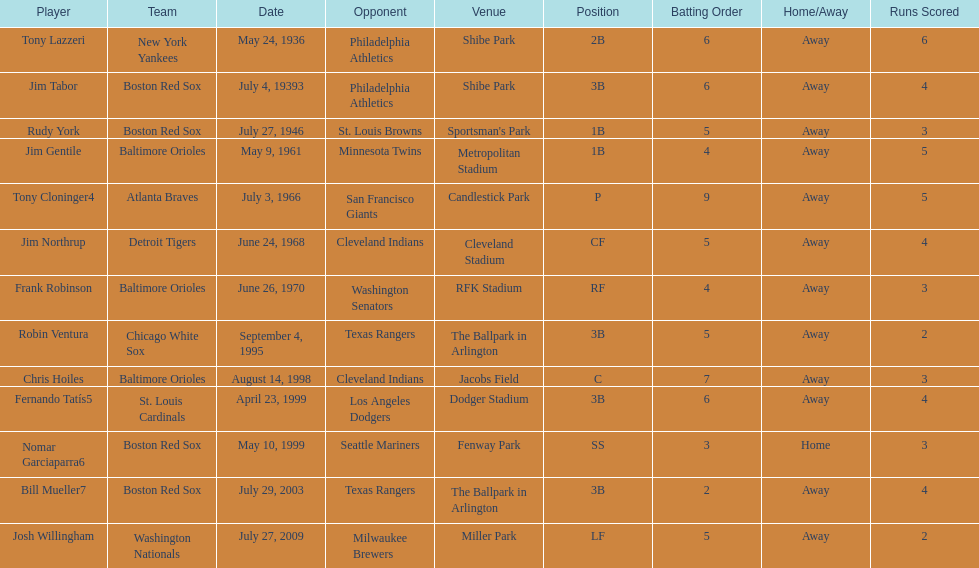Who is the first major league hitter to hit two grand slams in one game? Tony Lazzeri. 